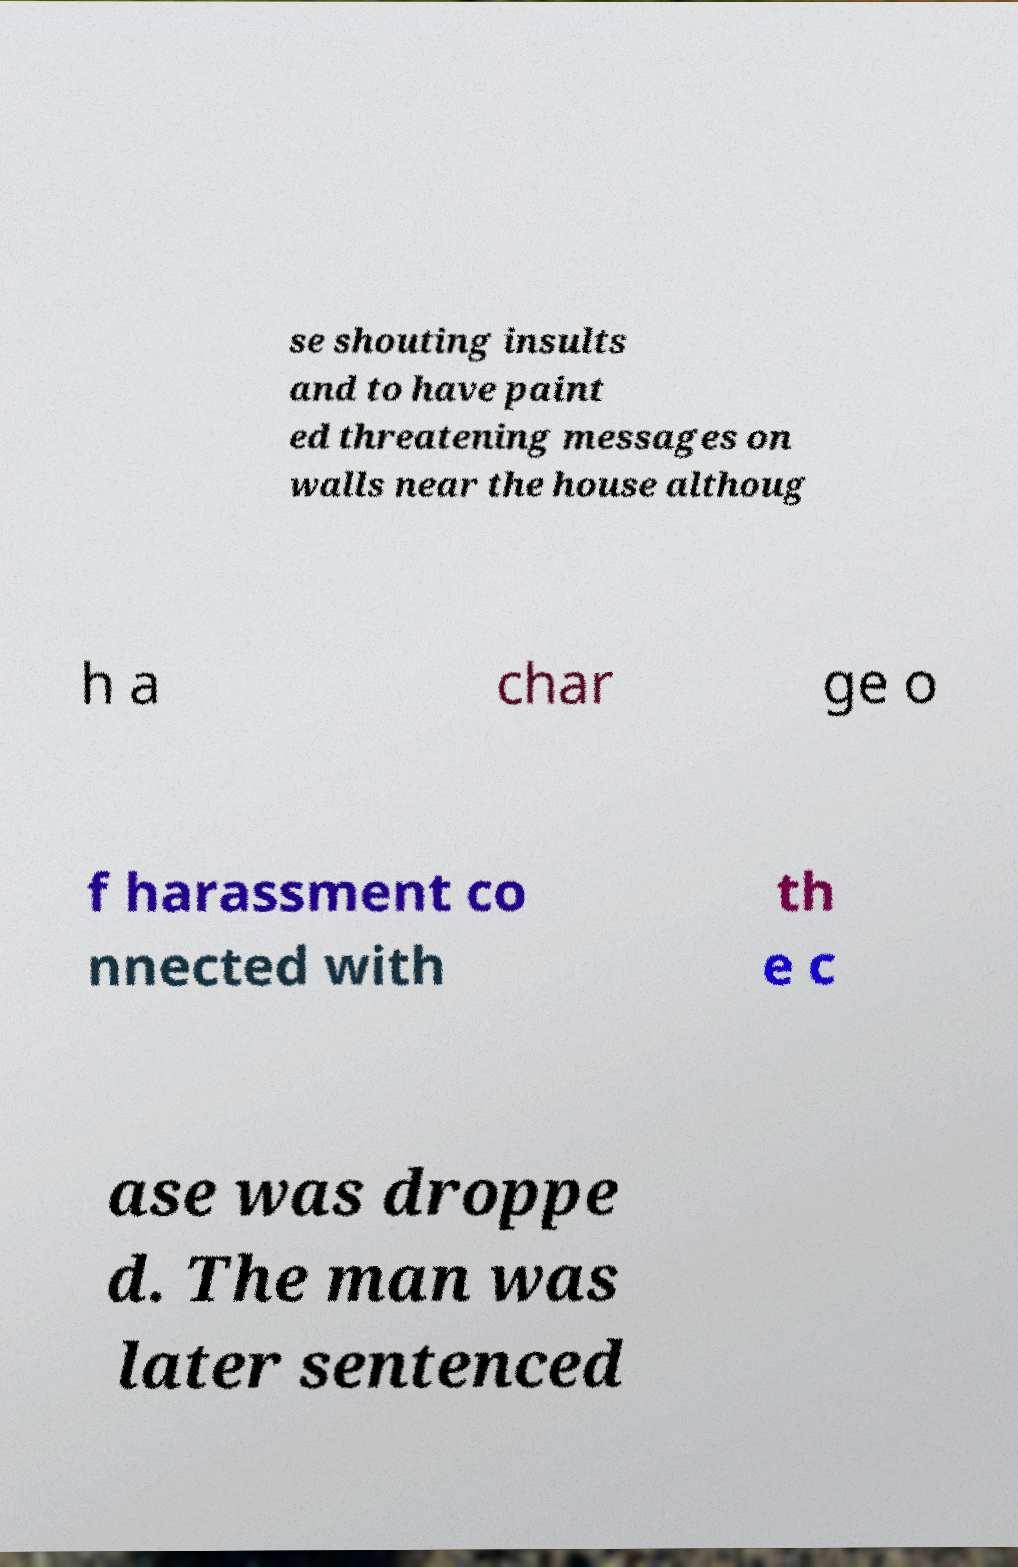There's text embedded in this image that I need extracted. Can you transcribe it verbatim? se shouting insults and to have paint ed threatening messages on walls near the house althoug h a char ge o f harassment co nnected with th e c ase was droppe d. The man was later sentenced 